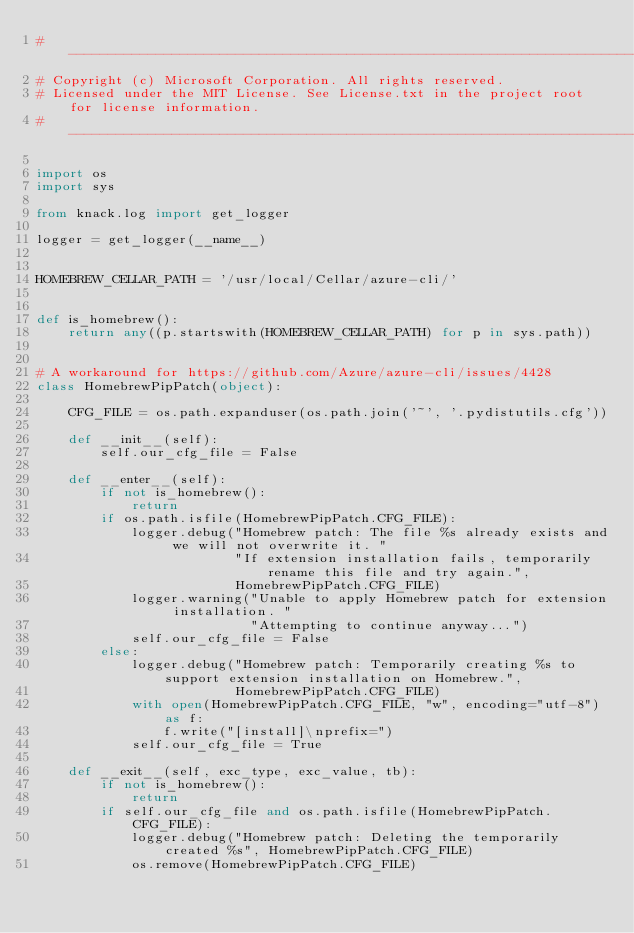<code> <loc_0><loc_0><loc_500><loc_500><_Python_># --------------------------------------------------------------------------------------------
# Copyright (c) Microsoft Corporation. All rights reserved.
# Licensed under the MIT License. See License.txt in the project root for license information.
# --------------------------------------------------------------------------------------------

import os
import sys

from knack.log import get_logger

logger = get_logger(__name__)


HOMEBREW_CELLAR_PATH = '/usr/local/Cellar/azure-cli/'


def is_homebrew():
    return any((p.startswith(HOMEBREW_CELLAR_PATH) for p in sys.path))


# A workaround for https://github.com/Azure/azure-cli/issues/4428
class HomebrewPipPatch(object):

    CFG_FILE = os.path.expanduser(os.path.join('~', '.pydistutils.cfg'))

    def __init__(self):
        self.our_cfg_file = False

    def __enter__(self):
        if not is_homebrew():
            return
        if os.path.isfile(HomebrewPipPatch.CFG_FILE):
            logger.debug("Homebrew patch: The file %s already exists and we will not overwrite it. "
                         "If extension installation fails, temporarily rename this file and try again.",
                         HomebrewPipPatch.CFG_FILE)
            logger.warning("Unable to apply Homebrew patch for extension installation. "
                           "Attempting to continue anyway...")
            self.our_cfg_file = False
        else:
            logger.debug("Homebrew patch: Temporarily creating %s to support extension installation on Homebrew.",
                         HomebrewPipPatch.CFG_FILE)
            with open(HomebrewPipPatch.CFG_FILE, "w", encoding="utf-8") as f:
                f.write("[install]\nprefix=")
            self.our_cfg_file = True

    def __exit__(self, exc_type, exc_value, tb):
        if not is_homebrew():
            return
        if self.our_cfg_file and os.path.isfile(HomebrewPipPatch.CFG_FILE):
            logger.debug("Homebrew patch: Deleting the temporarily created %s", HomebrewPipPatch.CFG_FILE)
            os.remove(HomebrewPipPatch.CFG_FILE)
</code> 